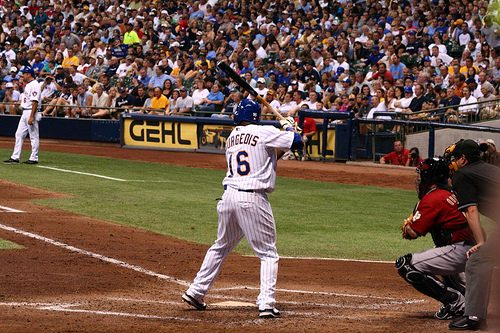Please identify all text content in this image. GEHL 16 HL 